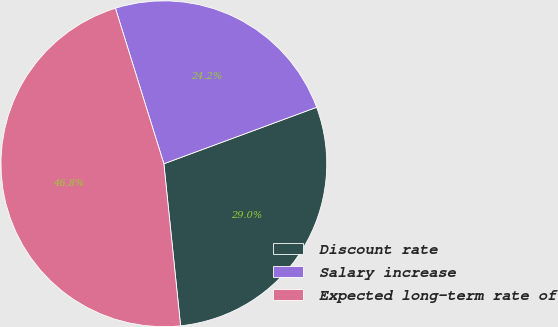Convert chart. <chart><loc_0><loc_0><loc_500><loc_500><pie_chart><fcel>Discount rate<fcel>Salary increase<fcel>Expected long-term rate of<nl><fcel>29.0%<fcel>24.17%<fcel>46.83%<nl></chart> 